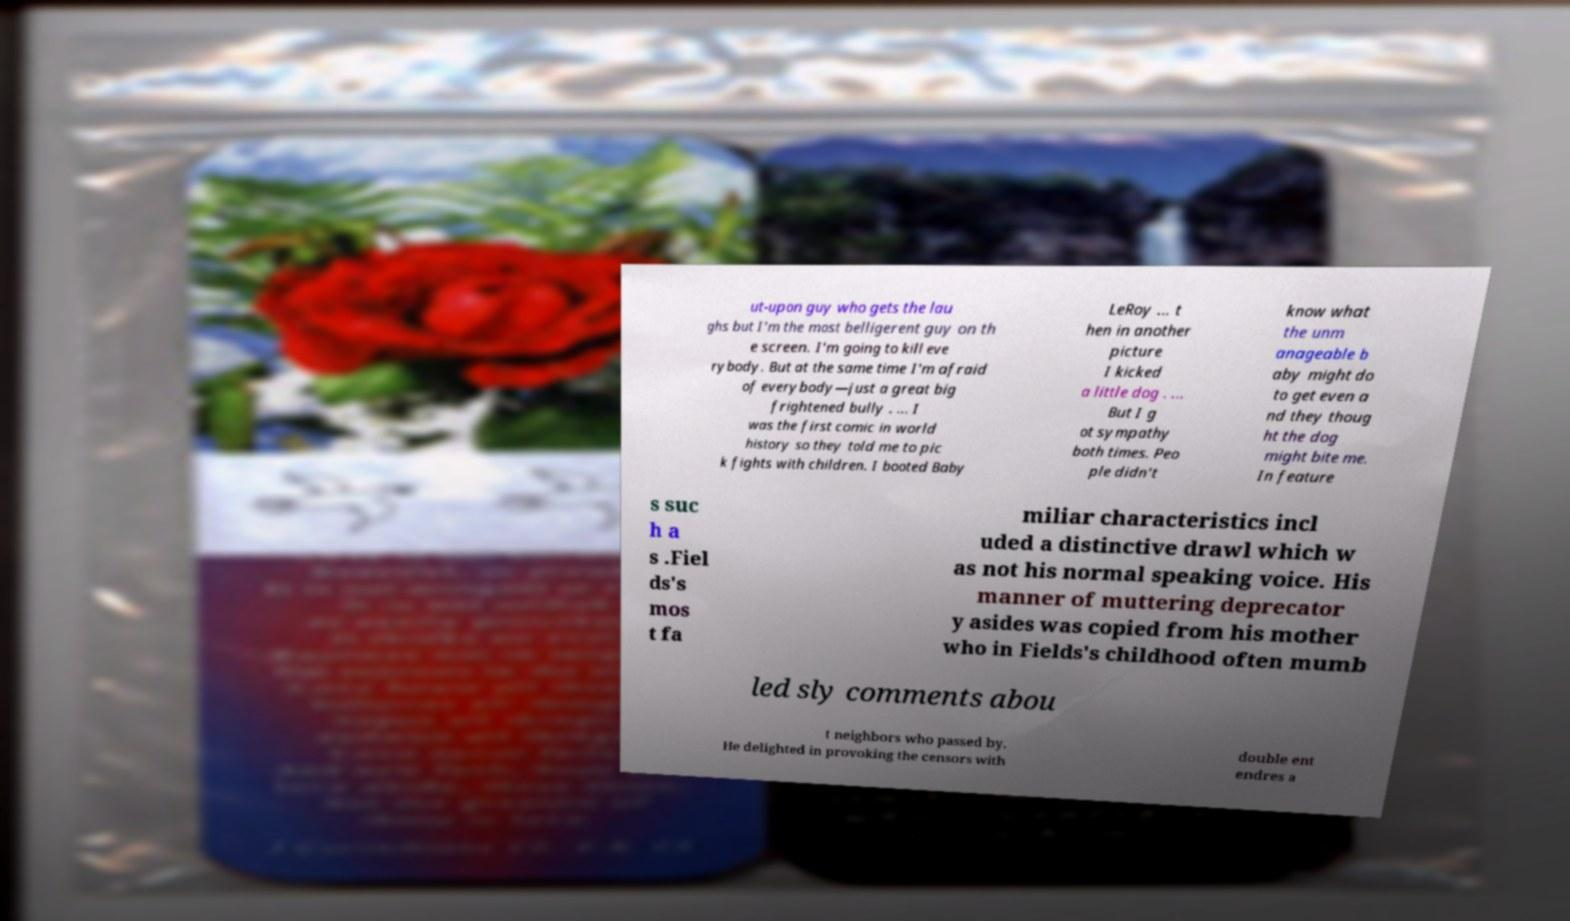Can you accurately transcribe the text from the provided image for me? ut-upon guy who gets the lau ghs but I'm the most belligerent guy on th e screen. I'm going to kill eve rybody. But at the same time I'm afraid of everybody—just a great big frightened bully . ... I was the first comic in world history so they told me to pic k fights with children. I booted Baby LeRoy ... t hen in another picture I kicked a little dog . ... But I g ot sympathy both times. Peo ple didn't know what the unm anageable b aby might do to get even a nd they thoug ht the dog might bite me. In feature s suc h a s .Fiel ds's mos t fa miliar characteristics incl uded a distinctive drawl which w as not his normal speaking voice. His manner of muttering deprecator y asides was copied from his mother who in Fields's childhood often mumb led sly comments abou t neighbors who passed by. He delighted in provoking the censors with double ent endres a 